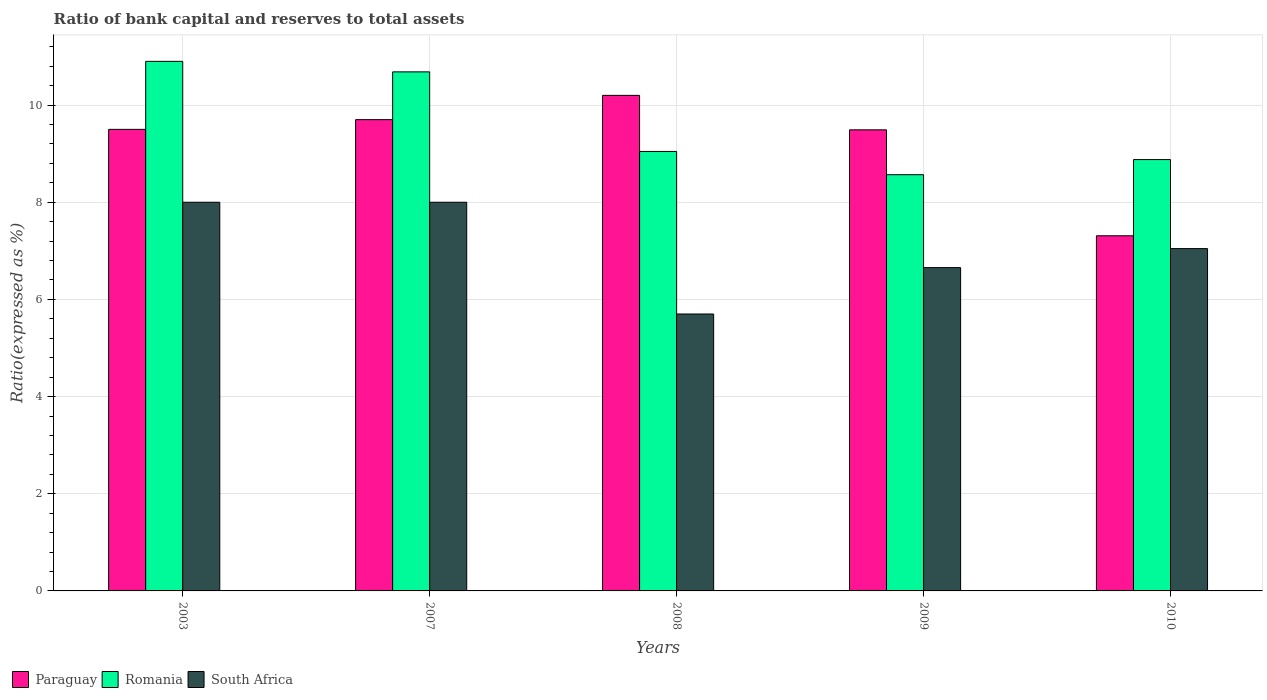How many different coloured bars are there?
Offer a very short reply. 3. How many groups of bars are there?
Your answer should be very brief. 5. Are the number of bars per tick equal to the number of legend labels?
Give a very brief answer. Yes. What is the label of the 3rd group of bars from the left?
Your answer should be very brief. 2008. In how many cases, is the number of bars for a given year not equal to the number of legend labels?
Your response must be concise. 0. What is the ratio of bank capital and reserves to total assets in Romania in 2007?
Your response must be concise. 10.68. Across all years, what is the maximum ratio of bank capital and reserves to total assets in South Africa?
Your response must be concise. 8. In which year was the ratio of bank capital and reserves to total assets in South Africa maximum?
Offer a very short reply. 2003. What is the total ratio of bank capital and reserves to total assets in South Africa in the graph?
Offer a terse response. 35.4. What is the difference between the ratio of bank capital and reserves to total assets in Paraguay in 2003 and that in 2010?
Provide a succinct answer. 2.19. What is the difference between the ratio of bank capital and reserves to total assets in Paraguay in 2007 and the ratio of bank capital and reserves to total assets in South Africa in 2003?
Your response must be concise. 1.7. What is the average ratio of bank capital and reserves to total assets in Romania per year?
Provide a short and direct response. 9.62. In the year 2003, what is the difference between the ratio of bank capital and reserves to total assets in Romania and ratio of bank capital and reserves to total assets in Paraguay?
Provide a succinct answer. 1.4. In how many years, is the ratio of bank capital and reserves to total assets in South Africa greater than 3.6 %?
Offer a terse response. 5. What is the ratio of the ratio of bank capital and reserves to total assets in South Africa in 2007 to that in 2010?
Offer a terse response. 1.14. Is the difference between the ratio of bank capital and reserves to total assets in Romania in 2003 and 2008 greater than the difference between the ratio of bank capital and reserves to total assets in Paraguay in 2003 and 2008?
Offer a very short reply. Yes. What is the difference between the highest and the second highest ratio of bank capital and reserves to total assets in South Africa?
Provide a short and direct response. 0. What is the difference between the highest and the lowest ratio of bank capital and reserves to total assets in Romania?
Your answer should be very brief. 2.33. In how many years, is the ratio of bank capital and reserves to total assets in Paraguay greater than the average ratio of bank capital and reserves to total assets in Paraguay taken over all years?
Keep it short and to the point. 4. Is the sum of the ratio of bank capital and reserves to total assets in South Africa in 2008 and 2009 greater than the maximum ratio of bank capital and reserves to total assets in Paraguay across all years?
Keep it short and to the point. Yes. What does the 1st bar from the left in 2008 represents?
Give a very brief answer. Paraguay. What does the 3rd bar from the right in 2003 represents?
Offer a very short reply. Paraguay. Is it the case that in every year, the sum of the ratio of bank capital and reserves to total assets in Romania and ratio of bank capital and reserves to total assets in Paraguay is greater than the ratio of bank capital and reserves to total assets in South Africa?
Make the answer very short. Yes. What is the difference between two consecutive major ticks on the Y-axis?
Your answer should be compact. 2. Are the values on the major ticks of Y-axis written in scientific E-notation?
Offer a terse response. No. Where does the legend appear in the graph?
Offer a terse response. Bottom left. How many legend labels are there?
Provide a succinct answer. 3. What is the title of the graph?
Your answer should be compact. Ratio of bank capital and reserves to total assets. What is the label or title of the Y-axis?
Offer a very short reply. Ratio(expressed as %). What is the Ratio(expressed as %) in Romania in 2003?
Keep it short and to the point. 10.9. What is the Ratio(expressed as %) in South Africa in 2003?
Ensure brevity in your answer.  8. What is the Ratio(expressed as %) of Romania in 2007?
Give a very brief answer. 10.68. What is the Ratio(expressed as %) in Paraguay in 2008?
Make the answer very short. 10.2. What is the Ratio(expressed as %) in Romania in 2008?
Your answer should be very brief. 9.05. What is the Ratio(expressed as %) in Paraguay in 2009?
Your answer should be compact. 9.49. What is the Ratio(expressed as %) in Romania in 2009?
Your answer should be very brief. 8.57. What is the Ratio(expressed as %) in South Africa in 2009?
Keep it short and to the point. 6.65. What is the Ratio(expressed as %) in Paraguay in 2010?
Ensure brevity in your answer.  7.31. What is the Ratio(expressed as %) of Romania in 2010?
Offer a very short reply. 8.88. What is the Ratio(expressed as %) in South Africa in 2010?
Provide a succinct answer. 7.05. Across all years, what is the maximum Ratio(expressed as %) in Paraguay?
Make the answer very short. 10.2. Across all years, what is the minimum Ratio(expressed as %) in Paraguay?
Your answer should be compact. 7.31. Across all years, what is the minimum Ratio(expressed as %) of Romania?
Provide a short and direct response. 8.57. Across all years, what is the minimum Ratio(expressed as %) in South Africa?
Keep it short and to the point. 5.7. What is the total Ratio(expressed as %) in Paraguay in the graph?
Your response must be concise. 46.2. What is the total Ratio(expressed as %) in Romania in the graph?
Keep it short and to the point. 48.08. What is the total Ratio(expressed as %) in South Africa in the graph?
Offer a very short reply. 35.4. What is the difference between the Ratio(expressed as %) in Romania in 2003 and that in 2007?
Provide a short and direct response. 0.22. What is the difference between the Ratio(expressed as %) in South Africa in 2003 and that in 2007?
Give a very brief answer. 0. What is the difference between the Ratio(expressed as %) in Romania in 2003 and that in 2008?
Your response must be concise. 1.85. What is the difference between the Ratio(expressed as %) of Paraguay in 2003 and that in 2009?
Your response must be concise. 0.01. What is the difference between the Ratio(expressed as %) in Romania in 2003 and that in 2009?
Keep it short and to the point. 2.33. What is the difference between the Ratio(expressed as %) in South Africa in 2003 and that in 2009?
Offer a terse response. 1.35. What is the difference between the Ratio(expressed as %) of Paraguay in 2003 and that in 2010?
Provide a succinct answer. 2.19. What is the difference between the Ratio(expressed as %) in Romania in 2003 and that in 2010?
Provide a short and direct response. 2.02. What is the difference between the Ratio(expressed as %) of South Africa in 2003 and that in 2010?
Your response must be concise. 0.95. What is the difference between the Ratio(expressed as %) of Paraguay in 2007 and that in 2008?
Your answer should be compact. -0.5. What is the difference between the Ratio(expressed as %) in Romania in 2007 and that in 2008?
Make the answer very short. 1.64. What is the difference between the Ratio(expressed as %) of Paraguay in 2007 and that in 2009?
Your answer should be very brief. 0.21. What is the difference between the Ratio(expressed as %) of Romania in 2007 and that in 2009?
Provide a short and direct response. 2.12. What is the difference between the Ratio(expressed as %) of South Africa in 2007 and that in 2009?
Keep it short and to the point. 1.35. What is the difference between the Ratio(expressed as %) of Paraguay in 2007 and that in 2010?
Provide a succinct answer. 2.39. What is the difference between the Ratio(expressed as %) in Romania in 2007 and that in 2010?
Your answer should be very brief. 1.81. What is the difference between the Ratio(expressed as %) of South Africa in 2007 and that in 2010?
Your answer should be compact. 0.95. What is the difference between the Ratio(expressed as %) in Paraguay in 2008 and that in 2009?
Your answer should be very brief. 0.71. What is the difference between the Ratio(expressed as %) of Romania in 2008 and that in 2009?
Your answer should be compact. 0.48. What is the difference between the Ratio(expressed as %) of South Africa in 2008 and that in 2009?
Make the answer very short. -0.95. What is the difference between the Ratio(expressed as %) of Paraguay in 2008 and that in 2010?
Make the answer very short. 2.89. What is the difference between the Ratio(expressed as %) of Romania in 2008 and that in 2010?
Offer a terse response. 0.17. What is the difference between the Ratio(expressed as %) in South Africa in 2008 and that in 2010?
Your answer should be compact. -1.35. What is the difference between the Ratio(expressed as %) of Paraguay in 2009 and that in 2010?
Provide a short and direct response. 2.18. What is the difference between the Ratio(expressed as %) of Romania in 2009 and that in 2010?
Your answer should be compact. -0.31. What is the difference between the Ratio(expressed as %) in South Africa in 2009 and that in 2010?
Provide a short and direct response. -0.39. What is the difference between the Ratio(expressed as %) in Paraguay in 2003 and the Ratio(expressed as %) in Romania in 2007?
Your answer should be very brief. -1.18. What is the difference between the Ratio(expressed as %) in Paraguay in 2003 and the Ratio(expressed as %) in South Africa in 2007?
Provide a short and direct response. 1.5. What is the difference between the Ratio(expressed as %) in Paraguay in 2003 and the Ratio(expressed as %) in Romania in 2008?
Provide a short and direct response. 0.45. What is the difference between the Ratio(expressed as %) in Paraguay in 2003 and the Ratio(expressed as %) in Romania in 2009?
Offer a terse response. 0.93. What is the difference between the Ratio(expressed as %) in Paraguay in 2003 and the Ratio(expressed as %) in South Africa in 2009?
Give a very brief answer. 2.85. What is the difference between the Ratio(expressed as %) of Romania in 2003 and the Ratio(expressed as %) of South Africa in 2009?
Provide a succinct answer. 4.25. What is the difference between the Ratio(expressed as %) of Paraguay in 2003 and the Ratio(expressed as %) of Romania in 2010?
Your answer should be compact. 0.62. What is the difference between the Ratio(expressed as %) of Paraguay in 2003 and the Ratio(expressed as %) of South Africa in 2010?
Give a very brief answer. 2.45. What is the difference between the Ratio(expressed as %) of Romania in 2003 and the Ratio(expressed as %) of South Africa in 2010?
Give a very brief answer. 3.85. What is the difference between the Ratio(expressed as %) in Paraguay in 2007 and the Ratio(expressed as %) in Romania in 2008?
Your answer should be compact. 0.65. What is the difference between the Ratio(expressed as %) of Romania in 2007 and the Ratio(expressed as %) of South Africa in 2008?
Provide a succinct answer. 4.98. What is the difference between the Ratio(expressed as %) of Paraguay in 2007 and the Ratio(expressed as %) of Romania in 2009?
Keep it short and to the point. 1.13. What is the difference between the Ratio(expressed as %) of Paraguay in 2007 and the Ratio(expressed as %) of South Africa in 2009?
Ensure brevity in your answer.  3.05. What is the difference between the Ratio(expressed as %) of Romania in 2007 and the Ratio(expressed as %) of South Africa in 2009?
Offer a very short reply. 4.03. What is the difference between the Ratio(expressed as %) of Paraguay in 2007 and the Ratio(expressed as %) of Romania in 2010?
Your answer should be compact. 0.82. What is the difference between the Ratio(expressed as %) in Paraguay in 2007 and the Ratio(expressed as %) in South Africa in 2010?
Your answer should be compact. 2.65. What is the difference between the Ratio(expressed as %) in Romania in 2007 and the Ratio(expressed as %) in South Africa in 2010?
Provide a short and direct response. 3.64. What is the difference between the Ratio(expressed as %) in Paraguay in 2008 and the Ratio(expressed as %) in Romania in 2009?
Make the answer very short. 1.63. What is the difference between the Ratio(expressed as %) of Paraguay in 2008 and the Ratio(expressed as %) of South Africa in 2009?
Provide a succinct answer. 3.55. What is the difference between the Ratio(expressed as %) of Romania in 2008 and the Ratio(expressed as %) of South Africa in 2009?
Provide a short and direct response. 2.39. What is the difference between the Ratio(expressed as %) of Paraguay in 2008 and the Ratio(expressed as %) of Romania in 2010?
Offer a very short reply. 1.32. What is the difference between the Ratio(expressed as %) in Paraguay in 2008 and the Ratio(expressed as %) in South Africa in 2010?
Your answer should be very brief. 3.15. What is the difference between the Ratio(expressed as %) of Romania in 2008 and the Ratio(expressed as %) of South Africa in 2010?
Make the answer very short. 2. What is the difference between the Ratio(expressed as %) in Paraguay in 2009 and the Ratio(expressed as %) in Romania in 2010?
Provide a short and direct response. 0.61. What is the difference between the Ratio(expressed as %) in Paraguay in 2009 and the Ratio(expressed as %) in South Africa in 2010?
Provide a short and direct response. 2.44. What is the difference between the Ratio(expressed as %) in Romania in 2009 and the Ratio(expressed as %) in South Africa in 2010?
Make the answer very short. 1.52. What is the average Ratio(expressed as %) of Paraguay per year?
Make the answer very short. 9.24. What is the average Ratio(expressed as %) of Romania per year?
Offer a terse response. 9.62. What is the average Ratio(expressed as %) in South Africa per year?
Keep it short and to the point. 7.08. In the year 2003, what is the difference between the Ratio(expressed as %) in Romania and Ratio(expressed as %) in South Africa?
Keep it short and to the point. 2.9. In the year 2007, what is the difference between the Ratio(expressed as %) of Paraguay and Ratio(expressed as %) of Romania?
Make the answer very short. -0.98. In the year 2007, what is the difference between the Ratio(expressed as %) in Romania and Ratio(expressed as %) in South Africa?
Your answer should be very brief. 2.68. In the year 2008, what is the difference between the Ratio(expressed as %) in Paraguay and Ratio(expressed as %) in Romania?
Your response must be concise. 1.15. In the year 2008, what is the difference between the Ratio(expressed as %) in Paraguay and Ratio(expressed as %) in South Africa?
Your response must be concise. 4.5. In the year 2008, what is the difference between the Ratio(expressed as %) in Romania and Ratio(expressed as %) in South Africa?
Make the answer very short. 3.35. In the year 2009, what is the difference between the Ratio(expressed as %) of Paraguay and Ratio(expressed as %) of Romania?
Your answer should be compact. 0.92. In the year 2009, what is the difference between the Ratio(expressed as %) of Paraguay and Ratio(expressed as %) of South Africa?
Keep it short and to the point. 2.84. In the year 2009, what is the difference between the Ratio(expressed as %) in Romania and Ratio(expressed as %) in South Africa?
Provide a short and direct response. 1.91. In the year 2010, what is the difference between the Ratio(expressed as %) of Paraguay and Ratio(expressed as %) of Romania?
Keep it short and to the point. -1.57. In the year 2010, what is the difference between the Ratio(expressed as %) of Paraguay and Ratio(expressed as %) of South Africa?
Give a very brief answer. 0.26. In the year 2010, what is the difference between the Ratio(expressed as %) in Romania and Ratio(expressed as %) in South Africa?
Your response must be concise. 1.83. What is the ratio of the Ratio(expressed as %) in Paraguay in 2003 to that in 2007?
Ensure brevity in your answer.  0.98. What is the ratio of the Ratio(expressed as %) in Romania in 2003 to that in 2007?
Make the answer very short. 1.02. What is the ratio of the Ratio(expressed as %) of Paraguay in 2003 to that in 2008?
Keep it short and to the point. 0.93. What is the ratio of the Ratio(expressed as %) of Romania in 2003 to that in 2008?
Your answer should be very brief. 1.21. What is the ratio of the Ratio(expressed as %) of South Africa in 2003 to that in 2008?
Keep it short and to the point. 1.4. What is the ratio of the Ratio(expressed as %) of Romania in 2003 to that in 2009?
Keep it short and to the point. 1.27. What is the ratio of the Ratio(expressed as %) of South Africa in 2003 to that in 2009?
Your answer should be very brief. 1.2. What is the ratio of the Ratio(expressed as %) of Paraguay in 2003 to that in 2010?
Your response must be concise. 1.3. What is the ratio of the Ratio(expressed as %) of Romania in 2003 to that in 2010?
Keep it short and to the point. 1.23. What is the ratio of the Ratio(expressed as %) of South Africa in 2003 to that in 2010?
Provide a short and direct response. 1.14. What is the ratio of the Ratio(expressed as %) in Paraguay in 2007 to that in 2008?
Provide a short and direct response. 0.95. What is the ratio of the Ratio(expressed as %) in Romania in 2007 to that in 2008?
Your answer should be very brief. 1.18. What is the ratio of the Ratio(expressed as %) of South Africa in 2007 to that in 2008?
Offer a terse response. 1.4. What is the ratio of the Ratio(expressed as %) of Paraguay in 2007 to that in 2009?
Keep it short and to the point. 1.02. What is the ratio of the Ratio(expressed as %) of Romania in 2007 to that in 2009?
Provide a succinct answer. 1.25. What is the ratio of the Ratio(expressed as %) in South Africa in 2007 to that in 2009?
Provide a short and direct response. 1.2. What is the ratio of the Ratio(expressed as %) of Paraguay in 2007 to that in 2010?
Your answer should be very brief. 1.33. What is the ratio of the Ratio(expressed as %) of Romania in 2007 to that in 2010?
Provide a short and direct response. 1.2. What is the ratio of the Ratio(expressed as %) in South Africa in 2007 to that in 2010?
Offer a terse response. 1.14. What is the ratio of the Ratio(expressed as %) of Paraguay in 2008 to that in 2009?
Your answer should be very brief. 1.07. What is the ratio of the Ratio(expressed as %) in Romania in 2008 to that in 2009?
Your answer should be compact. 1.06. What is the ratio of the Ratio(expressed as %) in South Africa in 2008 to that in 2009?
Offer a terse response. 0.86. What is the ratio of the Ratio(expressed as %) of Paraguay in 2008 to that in 2010?
Provide a short and direct response. 1.4. What is the ratio of the Ratio(expressed as %) in Romania in 2008 to that in 2010?
Give a very brief answer. 1.02. What is the ratio of the Ratio(expressed as %) in South Africa in 2008 to that in 2010?
Your answer should be compact. 0.81. What is the ratio of the Ratio(expressed as %) of Paraguay in 2009 to that in 2010?
Ensure brevity in your answer.  1.3. What is the ratio of the Ratio(expressed as %) in Romania in 2009 to that in 2010?
Offer a terse response. 0.96. What is the ratio of the Ratio(expressed as %) in South Africa in 2009 to that in 2010?
Your answer should be very brief. 0.94. What is the difference between the highest and the second highest Ratio(expressed as %) in Paraguay?
Your response must be concise. 0.5. What is the difference between the highest and the second highest Ratio(expressed as %) in Romania?
Your answer should be compact. 0.22. What is the difference between the highest and the second highest Ratio(expressed as %) of South Africa?
Your response must be concise. 0. What is the difference between the highest and the lowest Ratio(expressed as %) in Paraguay?
Keep it short and to the point. 2.89. What is the difference between the highest and the lowest Ratio(expressed as %) in Romania?
Keep it short and to the point. 2.33. What is the difference between the highest and the lowest Ratio(expressed as %) of South Africa?
Your answer should be compact. 2.3. 